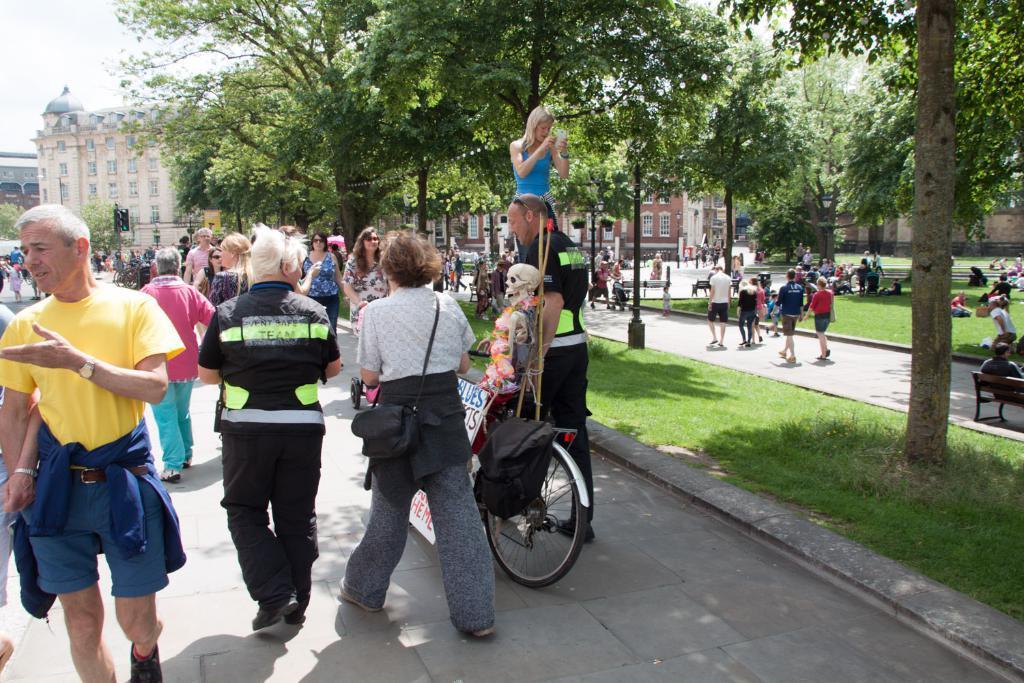Please provide a concise description of this image. In the picture I can see a group of people. I can see a few of them walking on the road and a few of them sitting on the green grass on the side of the road. I can see the trees on the side of the road. I can see a person holding the bicycle and there is a skeleton on the bicycle. In the background, I can see the building and a traffic signal pole. 